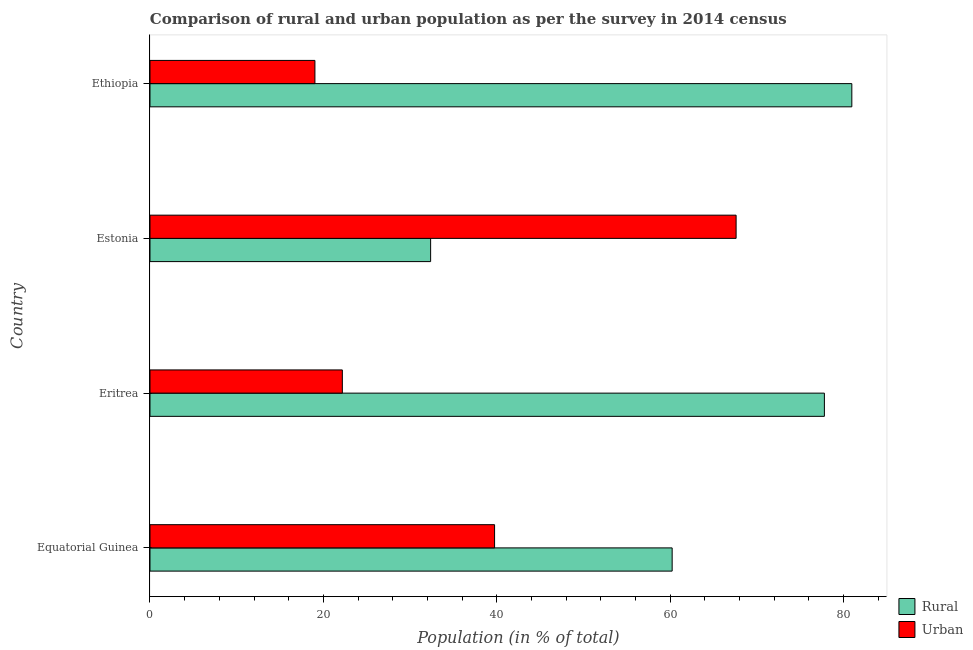How many different coloured bars are there?
Your answer should be very brief. 2. How many groups of bars are there?
Your response must be concise. 4. Are the number of bars on each tick of the Y-axis equal?
Ensure brevity in your answer.  Yes. How many bars are there on the 4th tick from the top?
Your answer should be compact. 2. What is the label of the 3rd group of bars from the top?
Give a very brief answer. Eritrea. What is the urban population in Estonia?
Your answer should be compact. 67.62. Across all countries, what is the maximum rural population?
Make the answer very short. 80.97. Across all countries, what is the minimum rural population?
Your answer should be very brief. 32.38. In which country was the rural population maximum?
Offer a very short reply. Ethiopia. In which country was the rural population minimum?
Ensure brevity in your answer.  Estonia. What is the total rural population in the graph?
Make the answer very short. 251.4. What is the difference between the urban population in Equatorial Guinea and that in Ethiopia?
Make the answer very short. 20.73. What is the difference between the urban population in Eritrea and the rural population in Equatorial Guinea?
Provide a short and direct response. -38.05. What is the average urban population per country?
Provide a short and direct response. 37.15. What is the difference between the urban population and rural population in Equatorial Guinea?
Your response must be concise. -20.49. In how many countries, is the rural population greater than 28 %?
Provide a short and direct response. 4. What is the ratio of the urban population in Equatorial Guinea to that in Eritrea?
Offer a terse response. 1.79. What is the difference between the highest and the second highest urban population?
Provide a succinct answer. 27.87. What is the difference between the highest and the lowest rural population?
Your response must be concise. 48.59. In how many countries, is the urban population greater than the average urban population taken over all countries?
Offer a terse response. 2. Is the sum of the rural population in Eritrea and Estonia greater than the maximum urban population across all countries?
Offer a terse response. Yes. What does the 1st bar from the top in Eritrea represents?
Provide a succinct answer. Urban. What does the 2nd bar from the bottom in Equatorial Guinea represents?
Keep it short and to the point. Urban. How many bars are there?
Give a very brief answer. 8. Are all the bars in the graph horizontal?
Offer a terse response. Yes. What is the difference between two consecutive major ticks on the X-axis?
Offer a terse response. 20. Are the values on the major ticks of X-axis written in scientific E-notation?
Offer a very short reply. No. Does the graph contain any zero values?
Offer a very short reply. No. Does the graph contain grids?
Give a very brief answer. No. Where does the legend appear in the graph?
Give a very brief answer. Bottom right. How many legend labels are there?
Make the answer very short. 2. What is the title of the graph?
Ensure brevity in your answer.  Comparison of rural and urban population as per the survey in 2014 census. What is the label or title of the X-axis?
Offer a very short reply. Population (in % of total). What is the Population (in % of total) in Rural in Equatorial Guinea?
Make the answer very short. 60.24. What is the Population (in % of total) in Urban in Equatorial Guinea?
Offer a terse response. 39.76. What is the Population (in % of total) of Rural in Eritrea?
Ensure brevity in your answer.  77.81. What is the Population (in % of total) of Urban in Eritrea?
Ensure brevity in your answer.  22.19. What is the Population (in % of total) of Rural in Estonia?
Ensure brevity in your answer.  32.38. What is the Population (in % of total) of Urban in Estonia?
Offer a very short reply. 67.62. What is the Population (in % of total) of Rural in Ethiopia?
Offer a terse response. 80.97. What is the Population (in % of total) of Urban in Ethiopia?
Your response must be concise. 19.03. Across all countries, what is the maximum Population (in % of total) of Rural?
Offer a terse response. 80.97. Across all countries, what is the maximum Population (in % of total) in Urban?
Your answer should be very brief. 67.62. Across all countries, what is the minimum Population (in % of total) in Rural?
Your answer should be very brief. 32.38. Across all countries, what is the minimum Population (in % of total) of Urban?
Provide a short and direct response. 19.03. What is the total Population (in % of total) in Rural in the graph?
Ensure brevity in your answer.  251.4. What is the total Population (in % of total) in Urban in the graph?
Your answer should be compact. 148.6. What is the difference between the Population (in % of total) in Rural in Equatorial Guinea and that in Eritrea?
Make the answer very short. -17.56. What is the difference between the Population (in % of total) in Urban in Equatorial Guinea and that in Eritrea?
Keep it short and to the point. 17.56. What is the difference between the Population (in % of total) in Rural in Equatorial Guinea and that in Estonia?
Your answer should be compact. 27.87. What is the difference between the Population (in % of total) in Urban in Equatorial Guinea and that in Estonia?
Make the answer very short. -27.87. What is the difference between the Population (in % of total) in Rural in Equatorial Guinea and that in Ethiopia?
Provide a succinct answer. -20.73. What is the difference between the Population (in % of total) in Urban in Equatorial Guinea and that in Ethiopia?
Keep it short and to the point. 20.73. What is the difference between the Population (in % of total) in Rural in Eritrea and that in Estonia?
Provide a succinct answer. 45.43. What is the difference between the Population (in % of total) in Urban in Eritrea and that in Estonia?
Keep it short and to the point. -45.43. What is the difference between the Population (in % of total) in Rural in Eritrea and that in Ethiopia?
Your response must be concise. -3.17. What is the difference between the Population (in % of total) in Urban in Eritrea and that in Ethiopia?
Provide a succinct answer. 3.17. What is the difference between the Population (in % of total) in Rural in Estonia and that in Ethiopia?
Offer a very short reply. -48.59. What is the difference between the Population (in % of total) of Urban in Estonia and that in Ethiopia?
Provide a succinct answer. 48.59. What is the difference between the Population (in % of total) in Rural in Equatorial Guinea and the Population (in % of total) in Urban in Eritrea?
Your answer should be very brief. 38.05. What is the difference between the Population (in % of total) in Rural in Equatorial Guinea and the Population (in % of total) in Urban in Estonia?
Provide a short and direct response. -7.38. What is the difference between the Population (in % of total) in Rural in Equatorial Guinea and the Population (in % of total) in Urban in Ethiopia?
Your response must be concise. 41.22. What is the difference between the Population (in % of total) of Rural in Eritrea and the Population (in % of total) of Urban in Estonia?
Offer a very short reply. 10.19. What is the difference between the Population (in % of total) of Rural in Eritrea and the Population (in % of total) of Urban in Ethiopia?
Give a very brief answer. 58.78. What is the difference between the Population (in % of total) in Rural in Estonia and the Population (in % of total) in Urban in Ethiopia?
Give a very brief answer. 13.35. What is the average Population (in % of total) of Rural per country?
Make the answer very short. 62.85. What is the average Population (in % of total) in Urban per country?
Your answer should be compact. 37.15. What is the difference between the Population (in % of total) of Rural and Population (in % of total) of Urban in Equatorial Guinea?
Provide a short and direct response. 20.49. What is the difference between the Population (in % of total) of Rural and Population (in % of total) of Urban in Eritrea?
Keep it short and to the point. 55.61. What is the difference between the Population (in % of total) in Rural and Population (in % of total) in Urban in Estonia?
Make the answer very short. -35.24. What is the difference between the Population (in % of total) in Rural and Population (in % of total) in Urban in Ethiopia?
Ensure brevity in your answer.  61.94. What is the ratio of the Population (in % of total) of Rural in Equatorial Guinea to that in Eritrea?
Make the answer very short. 0.77. What is the ratio of the Population (in % of total) of Urban in Equatorial Guinea to that in Eritrea?
Keep it short and to the point. 1.79. What is the ratio of the Population (in % of total) in Rural in Equatorial Guinea to that in Estonia?
Your answer should be compact. 1.86. What is the ratio of the Population (in % of total) in Urban in Equatorial Guinea to that in Estonia?
Provide a short and direct response. 0.59. What is the ratio of the Population (in % of total) of Rural in Equatorial Guinea to that in Ethiopia?
Your answer should be very brief. 0.74. What is the ratio of the Population (in % of total) of Urban in Equatorial Guinea to that in Ethiopia?
Ensure brevity in your answer.  2.09. What is the ratio of the Population (in % of total) of Rural in Eritrea to that in Estonia?
Your answer should be very brief. 2.4. What is the ratio of the Population (in % of total) of Urban in Eritrea to that in Estonia?
Provide a short and direct response. 0.33. What is the ratio of the Population (in % of total) of Rural in Eritrea to that in Ethiopia?
Your answer should be compact. 0.96. What is the ratio of the Population (in % of total) of Urban in Eritrea to that in Ethiopia?
Your answer should be very brief. 1.17. What is the ratio of the Population (in % of total) of Rural in Estonia to that in Ethiopia?
Ensure brevity in your answer.  0.4. What is the ratio of the Population (in % of total) of Urban in Estonia to that in Ethiopia?
Keep it short and to the point. 3.55. What is the difference between the highest and the second highest Population (in % of total) of Rural?
Give a very brief answer. 3.17. What is the difference between the highest and the second highest Population (in % of total) of Urban?
Your response must be concise. 27.87. What is the difference between the highest and the lowest Population (in % of total) in Rural?
Keep it short and to the point. 48.59. What is the difference between the highest and the lowest Population (in % of total) in Urban?
Make the answer very short. 48.59. 